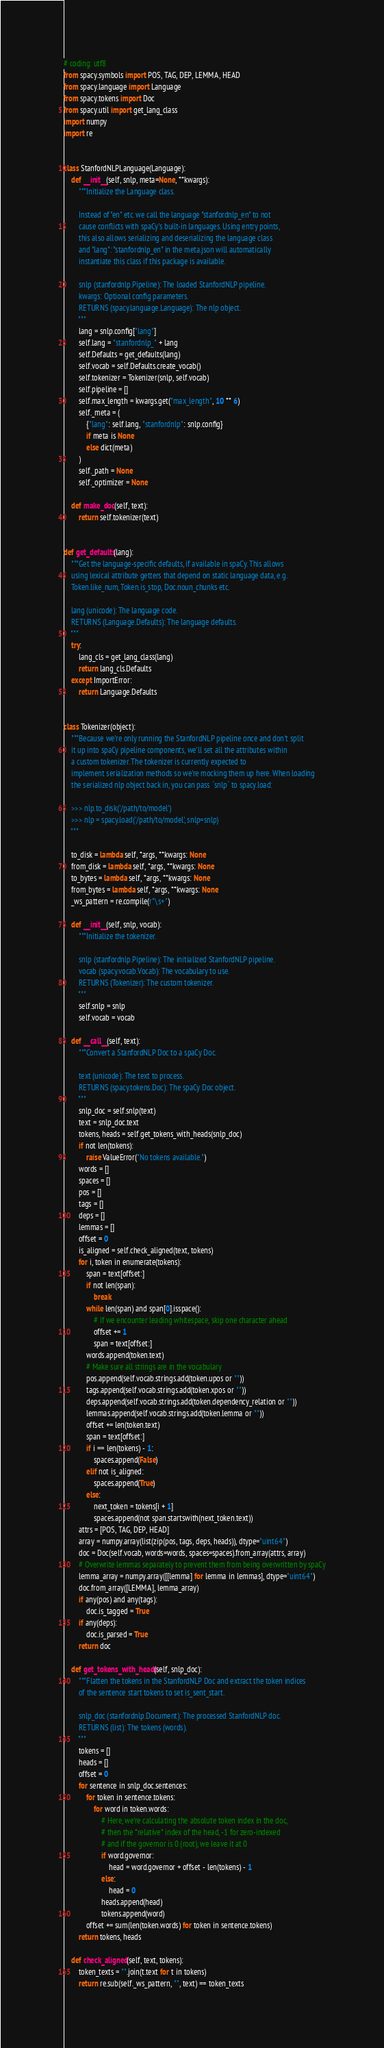<code> <loc_0><loc_0><loc_500><loc_500><_Python_># coding: utf8
from spacy.symbols import POS, TAG, DEP, LEMMA, HEAD
from spacy.language import Language
from spacy.tokens import Doc
from spacy.util import get_lang_class
import numpy
import re


class StanfordNLPLanguage(Language):
    def __init__(self, snlp, meta=None, **kwargs):
        """Initialize the Language class.

        Instead of "en" etc. we call the language "stanfordnlp_en" to not
        cause conflicts with spaCy's built-in languages. Using entry points,
        this also allows serializing and deserializing the language class
        and "lang": "stanfordnlp_en" in the meta.json will automatically
        instantiate this class if this package is available.

        snlp (stanfordnlp.Pipeline): The loaded StanfordNLP pipeline.
        kwargs: Optional config parameters.
        RETURNS (spacy.language.Language): The nlp object.
        """
        lang = snlp.config["lang"]
        self.lang = "stanfordnlp_" + lang
        self.Defaults = get_defaults(lang)
        self.vocab = self.Defaults.create_vocab()
        self.tokenizer = Tokenizer(snlp, self.vocab)
        self.pipeline = []
        self.max_length = kwargs.get("max_length", 10 ** 6)
        self._meta = (
            {"lang": self.lang, "stanfordnlp": snlp.config}
            if meta is None
            else dict(meta)
        )
        self._path = None
        self._optimizer = None

    def make_doc(self, text):
        return self.tokenizer(text)


def get_defaults(lang):
    """Get the language-specific defaults, if available in spaCy. This allows
    using lexical attribute getters that depend on static language data, e.g.
    Token.like_num, Token.is_stop, Doc.noun_chunks etc.

    lang (unicode): The language code.
    RETURNS (Language.Defaults): The language defaults.
    """
    try:
        lang_cls = get_lang_class(lang)
        return lang_cls.Defaults
    except ImportError:
        return Language.Defaults


class Tokenizer(object):
    """Because we're only running the StanfordNLP pipeline once and don't split
    it up into spaCy pipeline components, we'll set all the attributes within
    a custom tokenizer. The tokenizer is currently expected to
    implement serialization methods so we're mocking them up here. When loading
    the serialized nlp object back in, you can pass `snlp` to spacy.load:

    >>> nlp.to_disk('/path/to/model')
    >>> nlp = spacy.load('/path/to/model', snlp=snlp)
    """

    to_disk = lambda self, *args, **kwargs: None
    from_disk = lambda self, *args, **kwargs: None
    to_bytes = lambda self, *args, **kwargs: None
    from_bytes = lambda self, *args, **kwargs: None
    _ws_pattern = re.compile(r"\s+")

    def __init__(self, snlp, vocab):
        """Initialize the tokenizer.

        snlp (stanfordnlp.Pipeline): The initialized StanfordNLP pipeline.
        vocab (spacy.vocab.Vocab): The vocabulary to use.
        RETURNS (Tokenizer): The custom tokenizer.
        """
        self.snlp = snlp
        self.vocab = vocab

    def __call__(self, text):
        """Convert a StanfordNLP Doc to a spaCy Doc.

        text (unicode): The text to process.
        RETURNS (spacy.tokens.Doc): The spaCy Doc object.
        """
        snlp_doc = self.snlp(text)
        text = snlp_doc.text
        tokens, heads = self.get_tokens_with_heads(snlp_doc)
        if not len(tokens):
            raise ValueError("No tokens available.")
        words = []
        spaces = []
        pos = []
        tags = []
        deps = []
        lemmas = []
        offset = 0
        is_aligned = self.check_aligned(text, tokens)
        for i, token in enumerate(tokens):
            span = text[offset:]
            if not len(span):
                break
            while len(span) and span[0].isspace():
                # If we encounter leading whitespace, skip one character ahead
                offset += 1
                span = text[offset:]
            words.append(token.text)
            # Make sure all strings are in the vocabulary
            pos.append(self.vocab.strings.add(token.upos or ""))
            tags.append(self.vocab.strings.add(token.xpos or ""))
            deps.append(self.vocab.strings.add(token.dependency_relation or ""))
            lemmas.append(self.vocab.strings.add(token.lemma or ""))
            offset += len(token.text)
            span = text[offset:]
            if i == len(tokens) - 1:
                spaces.append(False)
            elif not is_aligned:
                spaces.append(True)
            else:
                next_token = tokens[i + 1]
                spaces.append(not span.startswith(next_token.text))
        attrs = [POS, TAG, DEP, HEAD]
        array = numpy.array(list(zip(pos, tags, deps, heads)), dtype="uint64")
        doc = Doc(self.vocab, words=words, spaces=spaces).from_array(attrs, array)
        # Overwrite lemmas separately to prevent them from being overwritten by spaCy
        lemma_array = numpy.array([[lemma] for lemma in lemmas], dtype="uint64")
        doc.from_array([LEMMA], lemma_array)
        if any(pos) and any(tags):
            doc.is_tagged = True
        if any(deps):
            doc.is_parsed = True
        return doc

    def get_tokens_with_heads(self, snlp_doc):
        """Flatten the tokens in the StanfordNLP Doc and extract the token indices
        of the sentence start tokens to set is_sent_start.

        snlp_doc (stanfordnlp.Document): The processed StanfordNLP doc.
        RETURNS (list): The tokens (words).
        """
        tokens = []
        heads = []
        offset = 0
        for sentence in snlp_doc.sentences:
            for token in sentence.tokens:
                for word in token.words:
                    # Here, we're calculating the absolute token index in the doc,
                    # then the *relative* index of the head, -1 for zero-indexed
                    # and if the governor is 0 (root), we leave it at 0
                    if word.governor:
                        head = word.governor + offset - len(tokens) - 1
                    else:
                        head = 0
                    heads.append(head)
                    tokens.append(word)
            offset += sum(len(token.words) for token in sentence.tokens)
        return tokens, heads

    def check_aligned(self, text, tokens):
        token_texts = "".join(t.text for t in tokens)
        return re.sub(self._ws_pattern, "", text) == token_texts
</code> 